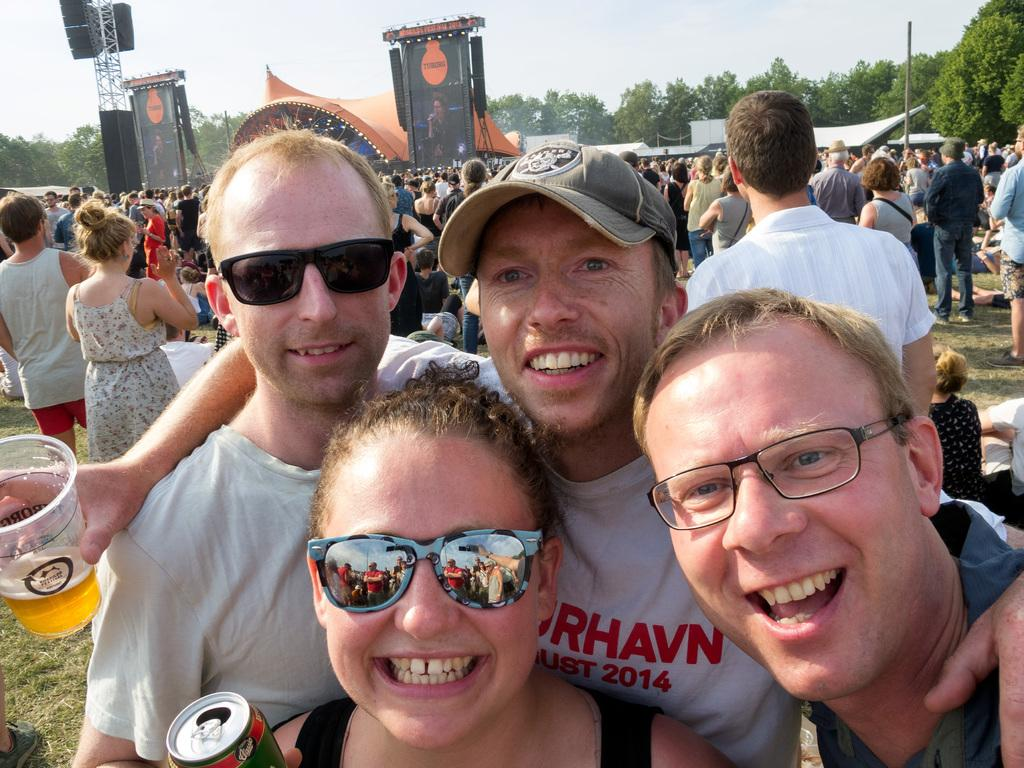How many people are in the image? There are people in the image, but the exact number is not specified. What are the people doing in the image? The people are standing and smiling in the image. What objects are the people holding in the image? The people are holding glasses and tins in the image. What can be seen in the background of the image? In the background of the image, there are tents, poles, and trees. What is visible at the top of the image? The sky is visible at the top of the image. What type of learning is taking place in the field in the image? There is no indication of any learning or field in the image; it features people standing and smiling while holding glasses and tins. How many twists are there in the pole in the image? There is no pole with twists present in the image; the background features poles without any visible twists. 